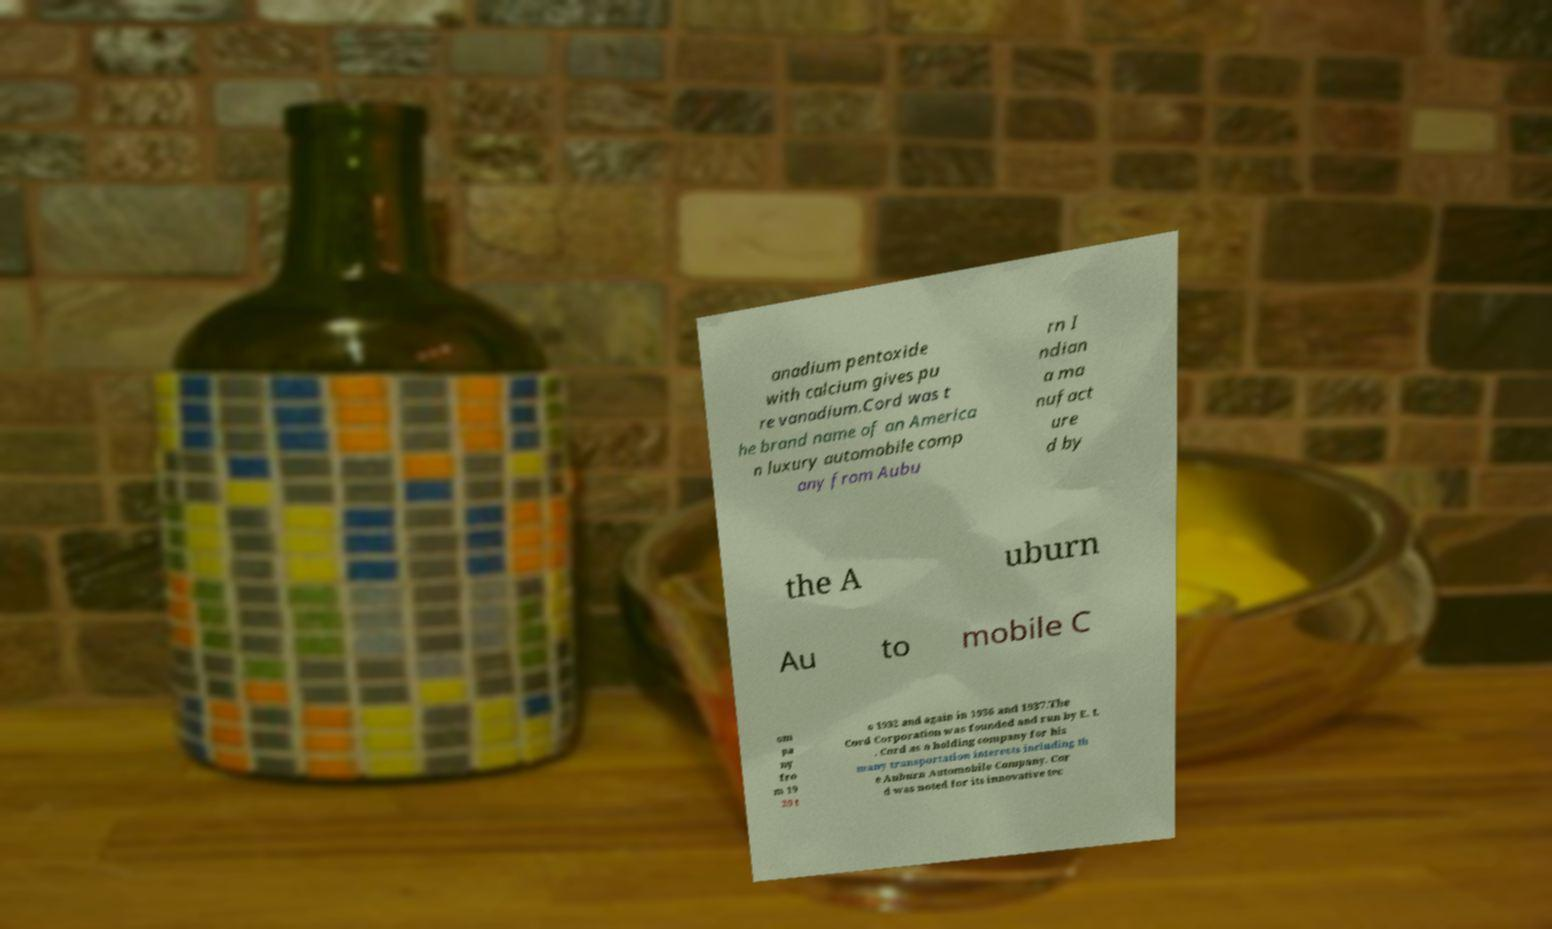Please identify and transcribe the text found in this image. anadium pentoxide with calcium gives pu re vanadium.Cord was t he brand name of an America n luxury automobile comp any from Aubu rn I ndian a ma nufact ure d by the A uburn Au to mobile C om pa ny fro m 19 29 t o 1932 and again in 1936 and 1937.The Cord Corporation was founded and run by E. L . Cord as a holding company for his many transportation interests including th e Auburn Automobile Company. Cor d was noted for its innovative tec 